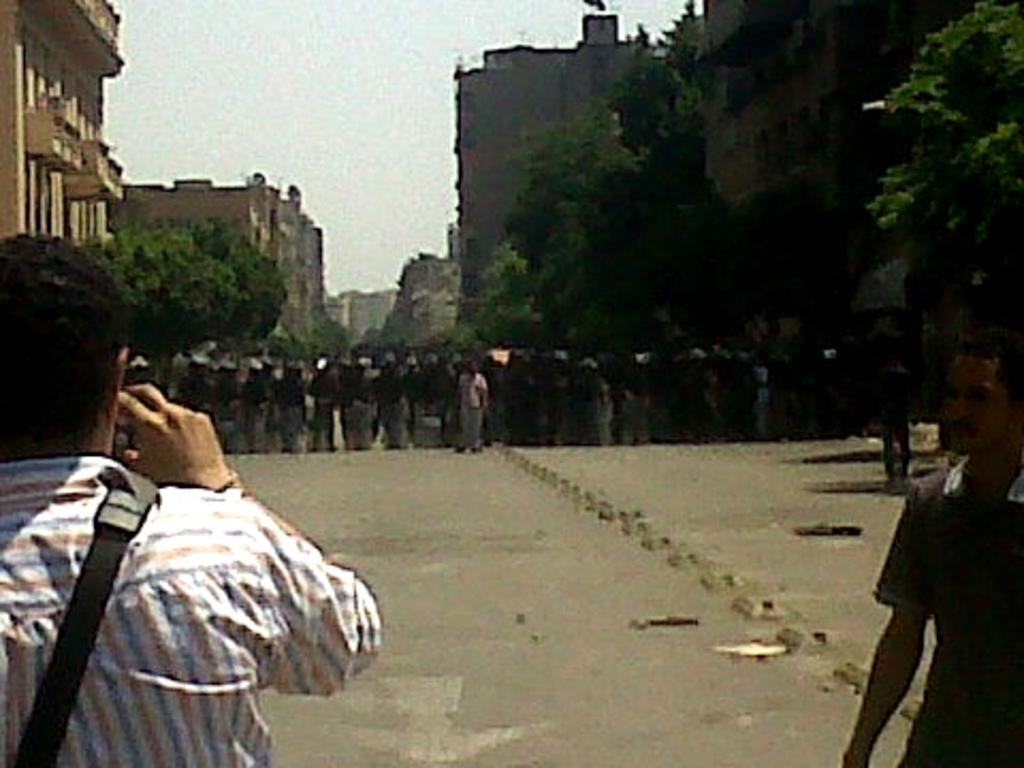How many people are present in the image? There are two persons in the image. What can be seen in the background of the image? There are trees, buildings, and the sky visible in the background of the image. What is the group of people doing in the image? The group of people is standing on the road in the image. What type of scarf is the yak wearing in the image? There is no yak present in the image, and therefore no scarf can be observed. 